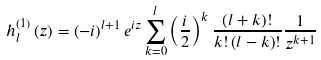<formula> <loc_0><loc_0><loc_500><loc_500>h _ { l } ^ { \left ( 1 \right ) } \left ( z \right ) = \left ( - i \right ) ^ { l + 1 } e ^ { i z } \sum _ { k = 0 } ^ { l } \left ( \frac { i } { 2 } \right ) ^ { k } \frac { \left ( l + k \right ) ! } { k ! \left ( l - k \right ) ! } \frac { 1 } { z ^ { k + 1 } }</formula> 